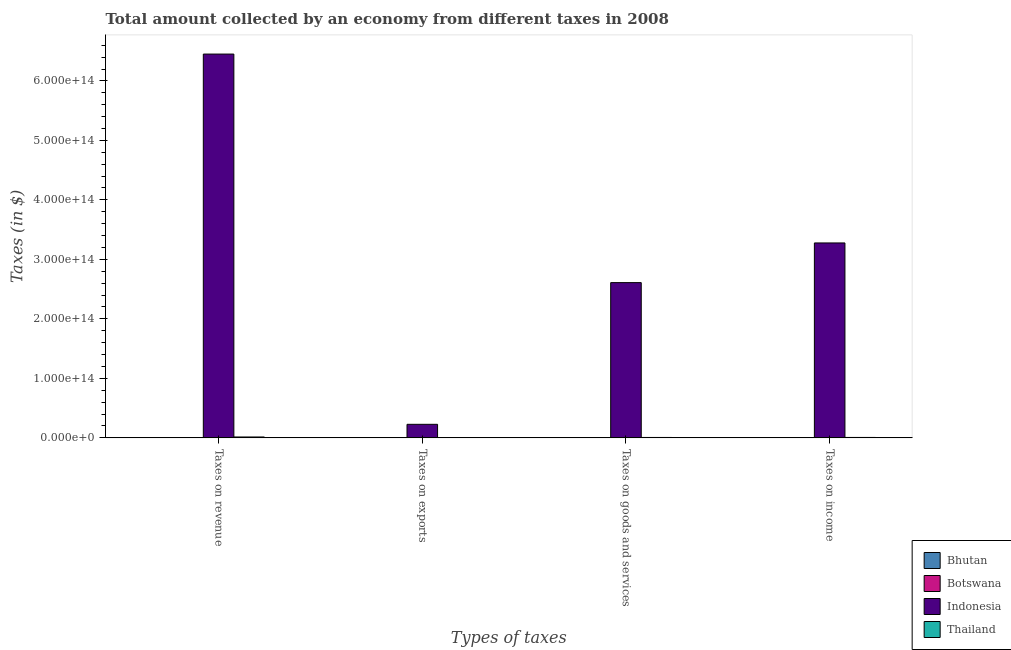How many groups of bars are there?
Provide a succinct answer. 4. Are the number of bars per tick equal to the number of legend labels?
Provide a short and direct response. Yes. How many bars are there on the 3rd tick from the left?
Provide a succinct answer. 4. What is the label of the 2nd group of bars from the left?
Your answer should be very brief. Taxes on exports. What is the amount collected as tax on goods in Thailand?
Ensure brevity in your answer.  6.74e+11. Across all countries, what is the maximum amount collected as tax on revenue?
Ensure brevity in your answer.  6.45e+14. Across all countries, what is the minimum amount collected as tax on revenue?
Ensure brevity in your answer.  4.61e+09. In which country was the amount collected as tax on income minimum?
Offer a very short reply. Bhutan. What is the total amount collected as tax on income in the graph?
Provide a succinct answer. 3.28e+14. What is the difference between the amount collected as tax on revenue in Indonesia and that in Bhutan?
Offer a terse response. 6.45e+14. What is the difference between the amount collected as tax on exports in Indonesia and the amount collected as tax on income in Thailand?
Your answer should be very brief. 2.21e+13. What is the average amount collected as tax on income per country?
Make the answer very short. 8.21e+13. What is the difference between the amount collected as tax on exports and amount collected as tax on income in Bhutan?
Keep it short and to the point. -2.55e+09. In how many countries, is the amount collected as tax on income greater than 440000000000000 $?
Offer a terse response. 0. What is the ratio of the amount collected as tax on exports in Botswana to that in Bhutan?
Your answer should be compact. 15.87. Is the difference between the amount collected as tax on goods in Botswana and Bhutan greater than the difference between the amount collected as tax on revenue in Botswana and Bhutan?
Provide a succinct answer. No. What is the difference between the highest and the second highest amount collected as tax on goods?
Make the answer very short. 2.60e+14. What is the difference between the highest and the lowest amount collected as tax on exports?
Provide a succinct answer. 2.28e+13. What does the 3rd bar from the left in Taxes on income represents?
Keep it short and to the point. Indonesia. What does the 4th bar from the right in Taxes on income represents?
Your response must be concise. Bhutan. Is it the case that in every country, the sum of the amount collected as tax on revenue and amount collected as tax on exports is greater than the amount collected as tax on goods?
Provide a succinct answer. Yes. Are all the bars in the graph horizontal?
Give a very brief answer. No. What is the difference between two consecutive major ticks on the Y-axis?
Your response must be concise. 1.00e+14. Does the graph contain any zero values?
Keep it short and to the point. No. Does the graph contain grids?
Provide a succinct answer. No. How are the legend labels stacked?
Offer a very short reply. Vertical. What is the title of the graph?
Give a very brief answer. Total amount collected by an economy from different taxes in 2008. What is the label or title of the X-axis?
Make the answer very short. Types of taxes. What is the label or title of the Y-axis?
Your response must be concise. Taxes (in $). What is the Taxes (in $) in Bhutan in Taxes on revenue?
Your answer should be compact. 4.61e+09. What is the Taxes (in $) of Botswana in Taxes on revenue?
Ensure brevity in your answer.  2.05e+1. What is the Taxes (in $) of Indonesia in Taxes on revenue?
Give a very brief answer. 6.45e+14. What is the Taxes (in $) of Thailand in Taxes on revenue?
Make the answer very short. 1.49e+12. What is the Taxes (in $) in Bhutan in Taxes on exports?
Ensure brevity in your answer.  1.04e+05. What is the Taxes (in $) in Botswana in Taxes on exports?
Make the answer very short. 1.65e+06. What is the Taxes (in $) of Indonesia in Taxes on exports?
Provide a short and direct response. 2.28e+13. What is the Taxes (in $) in Bhutan in Taxes on goods and services?
Offer a very short reply. 1.87e+09. What is the Taxes (in $) in Botswana in Taxes on goods and services?
Offer a terse response. 4.62e+09. What is the Taxes (in $) in Indonesia in Taxes on goods and services?
Provide a succinct answer. 2.61e+14. What is the Taxes (in $) in Thailand in Taxes on goods and services?
Provide a succinct answer. 6.74e+11. What is the Taxes (in $) in Bhutan in Taxes on income?
Keep it short and to the point. 2.55e+09. What is the Taxes (in $) in Botswana in Taxes on income?
Your response must be concise. 8.06e+09. What is the Taxes (in $) in Indonesia in Taxes on income?
Keep it short and to the point. 3.28e+14. What is the Taxes (in $) in Thailand in Taxes on income?
Ensure brevity in your answer.  7.13e+11. Across all Types of taxes, what is the maximum Taxes (in $) of Bhutan?
Your response must be concise. 4.61e+09. Across all Types of taxes, what is the maximum Taxes (in $) in Botswana?
Keep it short and to the point. 2.05e+1. Across all Types of taxes, what is the maximum Taxes (in $) in Indonesia?
Give a very brief answer. 6.45e+14. Across all Types of taxes, what is the maximum Taxes (in $) of Thailand?
Ensure brevity in your answer.  1.49e+12. Across all Types of taxes, what is the minimum Taxes (in $) of Bhutan?
Provide a short and direct response. 1.04e+05. Across all Types of taxes, what is the minimum Taxes (in $) in Botswana?
Your answer should be compact. 1.65e+06. Across all Types of taxes, what is the minimum Taxes (in $) in Indonesia?
Offer a very short reply. 2.28e+13. Across all Types of taxes, what is the minimum Taxes (in $) of Thailand?
Ensure brevity in your answer.  5.00e+08. What is the total Taxes (in $) of Bhutan in the graph?
Ensure brevity in your answer.  9.02e+09. What is the total Taxes (in $) in Botswana in the graph?
Offer a terse response. 3.31e+1. What is the total Taxes (in $) of Indonesia in the graph?
Provide a short and direct response. 1.26e+15. What is the total Taxes (in $) in Thailand in the graph?
Your answer should be compact. 2.88e+12. What is the difference between the Taxes (in $) in Bhutan in Taxes on revenue and that in Taxes on exports?
Provide a short and direct response. 4.61e+09. What is the difference between the Taxes (in $) of Botswana in Taxes on revenue and that in Taxes on exports?
Provide a succinct answer. 2.05e+1. What is the difference between the Taxes (in $) in Indonesia in Taxes on revenue and that in Taxes on exports?
Your answer should be compact. 6.22e+14. What is the difference between the Taxes (in $) in Thailand in Taxes on revenue and that in Taxes on exports?
Provide a succinct answer. 1.49e+12. What is the difference between the Taxes (in $) of Bhutan in Taxes on revenue and that in Taxes on goods and services?
Make the answer very short. 2.74e+09. What is the difference between the Taxes (in $) in Botswana in Taxes on revenue and that in Taxes on goods and services?
Your response must be concise. 1.58e+1. What is the difference between the Taxes (in $) of Indonesia in Taxes on revenue and that in Taxes on goods and services?
Offer a terse response. 3.84e+14. What is the difference between the Taxes (in $) in Thailand in Taxes on revenue and that in Taxes on goods and services?
Your response must be concise. 8.19e+11. What is the difference between the Taxes (in $) of Bhutan in Taxes on revenue and that in Taxes on income?
Your answer should be compact. 2.06e+09. What is the difference between the Taxes (in $) in Botswana in Taxes on revenue and that in Taxes on income?
Make the answer very short. 1.24e+1. What is the difference between the Taxes (in $) of Indonesia in Taxes on revenue and that in Taxes on income?
Provide a succinct answer. 3.17e+14. What is the difference between the Taxes (in $) in Thailand in Taxes on revenue and that in Taxes on income?
Provide a short and direct response. 7.81e+11. What is the difference between the Taxes (in $) of Bhutan in Taxes on exports and that in Taxes on goods and services?
Keep it short and to the point. -1.87e+09. What is the difference between the Taxes (in $) of Botswana in Taxes on exports and that in Taxes on goods and services?
Your answer should be very brief. -4.62e+09. What is the difference between the Taxes (in $) in Indonesia in Taxes on exports and that in Taxes on goods and services?
Keep it short and to the point. -2.38e+14. What is the difference between the Taxes (in $) in Thailand in Taxes on exports and that in Taxes on goods and services?
Your response must be concise. -6.74e+11. What is the difference between the Taxes (in $) in Bhutan in Taxes on exports and that in Taxes on income?
Give a very brief answer. -2.55e+09. What is the difference between the Taxes (in $) in Botswana in Taxes on exports and that in Taxes on income?
Your answer should be compact. -8.06e+09. What is the difference between the Taxes (in $) in Indonesia in Taxes on exports and that in Taxes on income?
Provide a short and direct response. -3.05e+14. What is the difference between the Taxes (in $) in Thailand in Taxes on exports and that in Taxes on income?
Keep it short and to the point. -7.12e+11. What is the difference between the Taxes (in $) of Bhutan in Taxes on goods and services and that in Taxes on income?
Make the answer very short. -6.77e+08. What is the difference between the Taxes (in $) of Botswana in Taxes on goods and services and that in Taxes on income?
Your response must be concise. -3.44e+09. What is the difference between the Taxes (in $) in Indonesia in Taxes on goods and services and that in Taxes on income?
Offer a terse response. -6.67e+13. What is the difference between the Taxes (in $) of Thailand in Taxes on goods and services and that in Taxes on income?
Your answer should be very brief. -3.86e+1. What is the difference between the Taxes (in $) in Bhutan in Taxes on revenue and the Taxes (in $) in Botswana in Taxes on exports?
Your answer should be very brief. 4.61e+09. What is the difference between the Taxes (in $) of Bhutan in Taxes on revenue and the Taxes (in $) of Indonesia in Taxes on exports?
Make the answer very short. -2.28e+13. What is the difference between the Taxes (in $) in Bhutan in Taxes on revenue and the Taxes (in $) in Thailand in Taxes on exports?
Keep it short and to the point. 4.11e+09. What is the difference between the Taxes (in $) of Botswana in Taxes on revenue and the Taxes (in $) of Indonesia in Taxes on exports?
Your answer should be compact. -2.27e+13. What is the difference between the Taxes (in $) of Botswana in Taxes on revenue and the Taxes (in $) of Thailand in Taxes on exports?
Give a very brief answer. 2.00e+1. What is the difference between the Taxes (in $) in Indonesia in Taxes on revenue and the Taxes (in $) in Thailand in Taxes on exports?
Offer a very short reply. 6.45e+14. What is the difference between the Taxes (in $) in Bhutan in Taxes on revenue and the Taxes (in $) in Botswana in Taxes on goods and services?
Provide a short and direct response. -9.83e+06. What is the difference between the Taxes (in $) in Bhutan in Taxes on revenue and the Taxes (in $) in Indonesia in Taxes on goods and services?
Ensure brevity in your answer.  -2.61e+14. What is the difference between the Taxes (in $) of Bhutan in Taxes on revenue and the Taxes (in $) of Thailand in Taxes on goods and services?
Offer a terse response. -6.69e+11. What is the difference between the Taxes (in $) of Botswana in Taxes on revenue and the Taxes (in $) of Indonesia in Taxes on goods and services?
Give a very brief answer. -2.61e+14. What is the difference between the Taxes (in $) of Botswana in Taxes on revenue and the Taxes (in $) of Thailand in Taxes on goods and services?
Offer a terse response. -6.54e+11. What is the difference between the Taxes (in $) in Indonesia in Taxes on revenue and the Taxes (in $) in Thailand in Taxes on goods and services?
Offer a very short reply. 6.44e+14. What is the difference between the Taxes (in $) of Bhutan in Taxes on revenue and the Taxes (in $) of Botswana in Taxes on income?
Your answer should be very brief. -3.45e+09. What is the difference between the Taxes (in $) of Bhutan in Taxes on revenue and the Taxes (in $) of Indonesia in Taxes on income?
Your response must be concise. -3.28e+14. What is the difference between the Taxes (in $) of Bhutan in Taxes on revenue and the Taxes (in $) of Thailand in Taxes on income?
Provide a short and direct response. -7.08e+11. What is the difference between the Taxes (in $) in Botswana in Taxes on revenue and the Taxes (in $) in Indonesia in Taxes on income?
Give a very brief answer. -3.28e+14. What is the difference between the Taxes (in $) in Botswana in Taxes on revenue and the Taxes (in $) in Thailand in Taxes on income?
Your answer should be compact. -6.92e+11. What is the difference between the Taxes (in $) in Indonesia in Taxes on revenue and the Taxes (in $) in Thailand in Taxes on income?
Keep it short and to the point. 6.44e+14. What is the difference between the Taxes (in $) in Bhutan in Taxes on exports and the Taxes (in $) in Botswana in Taxes on goods and services?
Keep it short and to the point. -4.62e+09. What is the difference between the Taxes (in $) of Bhutan in Taxes on exports and the Taxes (in $) of Indonesia in Taxes on goods and services?
Offer a very short reply. -2.61e+14. What is the difference between the Taxes (in $) in Bhutan in Taxes on exports and the Taxes (in $) in Thailand in Taxes on goods and services?
Offer a very short reply. -6.74e+11. What is the difference between the Taxes (in $) in Botswana in Taxes on exports and the Taxes (in $) in Indonesia in Taxes on goods and services?
Keep it short and to the point. -2.61e+14. What is the difference between the Taxes (in $) of Botswana in Taxes on exports and the Taxes (in $) of Thailand in Taxes on goods and services?
Keep it short and to the point. -6.74e+11. What is the difference between the Taxes (in $) in Indonesia in Taxes on exports and the Taxes (in $) in Thailand in Taxes on goods and services?
Ensure brevity in your answer.  2.21e+13. What is the difference between the Taxes (in $) of Bhutan in Taxes on exports and the Taxes (in $) of Botswana in Taxes on income?
Provide a short and direct response. -8.06e+09. What is the difference between the Taxes (in $) in Bhutan in Taxes on exports and the Taxes (in $) in Indonesia in Taxes on income?
Provide a succinct answer. -3.28e+14. What is the difference between the Taxes (in $) of Bhutan in Taxes on exports and the Taxes (in $) of Thailand in Taxes on income?
Keep it short and to the point. -7.13e+11. What is the difference between the Taxes (in $) of Botswana in Taxes on exports and the Taxes (in $) of Indonesia in Taxes on income?
Offer a terse response. -3.28e+14. What is the difference between the Taxes (in $) in Botswana in Taxes on exports and the Taxes (in $) in Thailand in Taxes on income?
Your answer should be very brief. -7.13e+11. What is the difference between the Taxes (in $) in Indonesia in Taxes on exports and the Taxes (in $) in Thailand in Taxes on income?
Your answer should be very brief. 2.21e+13. What is the difference between the Taxes (in $) in Bhutan in Taxes on goods and services and the Taxes (in $) in Botswana in Taxes on income?
Your answer should be compact. -6.19e+09. What is the difference between the Taxes (in $) in Bhutan in Taxes on goods and services and the Taxes (in $) in Indonesia in Taxes on income?
Offer a very short reply. -3.28e+14. What is the difference between the Taxes (in $) of Bhutan in Taxes on goods and services and the Taxes (in $) of Thailand in Taxes on income?
Offer a very short reply. -7.11e+11. What is the difference between the Taxes (in $) of Botswana in Taxes on goods and services and the Taxes (in $) of Indonesia in Taxes on income?
Give a very brief answer. -3.28e+14. What is the difference between the Taxes (in $) in Botswana in Taxes on goods and services and the Taxes (in $) in Thailand in Taxes on income?
Your answer should be very brief. -7.08e+11. What is the difference between the Taxes (in $) of Indonesia in Taxes on goods and services and the Taxes (in $) of Thailand in Taxes on income?
Give a very brief answer. 2.60e+14. What is the average Taxes (in $) in Bhutan per Types of taxes?
Ensure brevity in your answer.  2.26e+09. What is the average Taxes (in $) in Botswana per Types of taxes?
Your answer should be compact. 8.28e+09. What is the average Taxes (in $) in Indonesia per Types of taxes?
Give a very brief answer. 3.14e+14. What is the average Taxes (in $) in Thailand per Types of taxes?
Give a very brief answer. 7.20e+11. What is the difference between the Taxes (in $) of Bhutan and Taxes (in $) of Botswana in Taxes on revenue?
Provide a short and direct response. -1.58e+1. What is the difference between the Taxes (in $) of Bhutan and Taxes (in $) of Indonesia in Taxes on revenue?
Your response must be concise. -6.45e+14. What is the difference between the Taxes (in $) in Bhutan and Taxes (in $) in Thailand in Taxes on revenue?
Ensure brevity in your answer.  -1.49e+12. What is the difference between the Taxes (in $) in Botswana and Taxes (in $) in Indonesia in Taxes on revenue?
Your response must be concise. -6.45e+14. What is the difference between the Taxes (in $) of Botswana and Taxes (in $) of Thailand in Taxes on revenue?
Provide a succinct answer. -1.47e+12. What is the difference between the Taxes (in $) in Indonesia and Taxes (in $) in Thailand in Taxes on revenue?
Your response must be concise. 6.44e+14. What is the difference between the Taxes (in $) of Bhutan and Taxes (in $) of Botswana in Taxes on exports?
Provide a short and direct response. -1.55e+06. What is the difference between the Taxes (in $) in Bhutan and Taxes (in $) in Indonesia in Taxes on exports?
Your answer should be compact. -2.28e+13. What is the difference between the Taxes (in $) of Bhutan and Taxes (in $) of Thailand in Taxes on exports?
Provide a short and direct response. -5.00e+08. What is the difference between the Taxes (in $) of Botswana and Taxes (in $) of Indonesia in Taxes on exports?
Offer a terse response. -2.28e+13. What is the difference between the Taxes (in $) of Botswana and Taxes (in $) of Thailand in Taxes on exports?
Provide a succinct answer. -4.98e+08. What is the difference between the Taxes (in $) in Indonesia and Taxes (in $) in Thailand in Taxes on exports?
Offer a very short reply. 2.28e+13. What is the difference between the Taxes (in $) of Bhutan and Taxes (in $) of Botswana in Taxes on goods and services?
Offer a very short reply. -2.75e+09. What is the difference between the Taxes (in $) in Bhutan and Taxes (in $) in Indonesia in Taxes on goods and services?
Provide a short and direct response. -2.61e+14. What is the difference between the Taxes (in $) of Bhutan and Taxes (in $) of Thailand in Taxes on goods and services?
Keep it short and to the point. -6.72e+11. What is the difference between the Taxes (in $) of Botswana and Taxes (in $) of Indonesia in Taxes on goods and services?
Your answer should be compact. -2.61e+14. What is the difference between the Taxes (in $) of Botswana and Taxes (in $) of Thailand in Taxes on goods and services?
Give a very brief answer. -6.69e+11. What is the difference between the Taxes (in $) in Indonesia and Taxes (in $) in Thailand in Taxes on goods and services?
Ensure brevity in your answer.  2.60e+14. What is the difference between the Taxes (in $) of Bhutan and Taxes (in $) of Botswana in Taxes on income?
Ensure brevity in your answer.  -5.51e+09. What is the difference between the Taxes (in $) of Bhutan and Taxes (in $) of Indonesia in Taxes on income?
Provide a succinct answer. -3.28e+14. What is the difference between the Taxes (in $) of Bhutan and Taxes (in $) of Thailand in Taxes on income?
Provide a succinct answer. -7.10e+11. What is the difference between the Taxes (in $) in Botswana and Taxes (in $) in Indonesia in Taxes on income?
Provide a succinct answer. -3.28e+14. What is the difference between the Taxes (in $) of Botswana and Taxes (in $) of Thailand in Taxes on income?
Make the answer very short. -7.05e+11. What is the difference between the Taxes (in $) in Indonesia and Taxes (in $) in Thailand in Taxes on income?
Offer a terse response. 3.27e+14. What is the ratio of the Taxes (in $) of Bhutan in Taxes on revenue to that in Taxes on exports?
Give a very brief answer. 4.43e+04. What is the ratio of the Taxes (in $) of Botswana in Taxes on revenue to that in Taxes on exports?
Your answer should be very brief. 1.24e+04. What is the ratio of the Taxes (in $) of Indonesia in Taxes on revenue to that in Taxes on exports?
Your answer should be very brief. 28.34. What is the ratio of the Taxes (in $) of Thailand in Taxes on revenue to that in Taxes on exports?
Make the answer very short. 2986.8. What is the ratio of the Taxes (in $) of Bhutan in Taxes on revenue to that in Taxes on goods and services?
Your response must be concise. 2.46. What is the ratio of the Taxes (in $) of Botswana in Taxes on revenue to that in Taxes on goods and services?
Offer a terse response. 4.43. What is the ratio of the Taxes (in $) in Indonesia in Taxes on revenue to that in Taxes on goods and services?
Provide a short and direct response. 2.47. What is the ratio of the Taxes (in $) in Thailand in Taxes on revenue to that in Taxes on goods and services?
Your answer should be very brief. 2.22. What is the ratio of the Taxes (in $) of Bhutan in Taxes on revenue to that in Taxes on income?
Offer a terse response. 1.81. What is the ratio of the Taxes (in $) in Botswana in Taxes on revenue to that in Taxes on income?
Make the answer very short. 2.54. What is the ratio of the Taxes (in $) of Indonesia in Taxes on revenue to that in Taxes on income?
Provide a succinct answer. 1.97. What is the ratio of the Taxes (in $) of Thailand in Taxes on revenue to that in Taxes on income?
Keep it short and to the point. 2.1. What is the ratio of the Taxes (in $) of Indonesia in Taxes on exports to that in Taxes on goods and services?
Offer a very short reply. 0.09. What is the ratio of the Taxes (in $) of Thailand in Taxes on exports to that in Taxes on goods and services?
Make the answer very short. 0. What is the ratio of the Taxes (in $) in Indonesia in Taxes on exports to that in Taxes on income?
Offer a terse response. 0.07. What is the ratio of the Taxes (in $) of Thailand in Taxes on exports to that in Taxes on income?
Offer a terse response. 0. What is the ratio of the Taxes (in $) in Bhutan in Taxes on goods and services to that in Taxes on income?
Your answer should be very brief. 0.73. What is the ratio of the Taxes (in $) in Botswana in Taxes on goods and services to that in Taxes on income?
Your answer should be compact. 0.57. What is the ratio of the Taxes (in $) in Indonesia in Taxes on goods and services to that in Taxes on income?
Ensure brevity in your answer.  0.8. What is the ratio of the Taxes (in $) of Thailand in Taxes on goods and services to that in Taxes on income?
Keep it short and to the point. 0.95. What is the difference between the highest and the second highest Taxes (in $) of Bhutan?
Offer a very short reply. 2.06e+09. What is the difference between the highest and the second highest Taxes (in $) in Botswana?
Your answer should be very brief. 1.24e+1. What is the difference between the highest and the second highest Taxes (in $) of Indonesia?
Provide a short and direct response. 3.17e+14. What is the difference between the highest and the second highest Taxes (in $) of Thailand?
Keep it short and to the point. 7.81e+11. What is the difference between the highest and the lowest Taxes (in $) in Bhutan?
Provide a succinct answer. 4.61e+09. What is the difference between the highest and the lowest Taxes (in $) in Botswana?
Offer a very short reply. 2.05e+1. What is the difference between the highest and the lowest Taxes (in $) in Indonesia?
Provide a succinct answer. 6.22e+14. What is the difference between the highest and the lowest Taxes (in $) in Thailand?
Make the answer very short. 1.49e+12. 